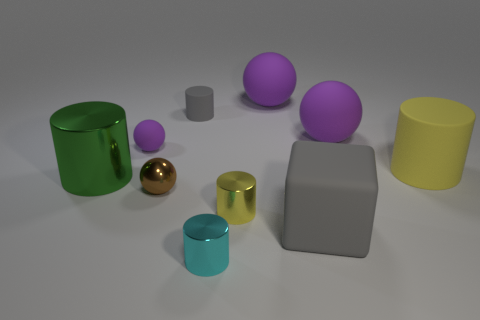Is the number of balls to the right of the tiny gray cylinder greater than the number of purple balls?
Make the answer very short. No. How many large green cylinders are behind the big yellow thing?
Ensure brevity in your answer.  0. What shape is the small thing that is the same color as the rubber block?
Make the answer very short. Cylinder. There is a gray thing that is right of the gray thing behind the small brown object; is there a small purple matte object that is in front of it?
Make the answer very short. No. Do the brown object and the gray matte cylinder have the same size?
Ensure brevity in your answer.  Yes. Is the number of yellow shiny objects that are to the left of the big shiny cylinder the same as the number of small metal things in front of the small brown ball?
Offer a terse response. No. What shape is the tiny thing behind the tiny purple rubber thing?
Offer a very short reply. Cylinder. The gray matte object that is the same size as the green shiny cylinder is what shape?
Provide a succinct answer. Cube. What is the color of the large cylinder that is behind the cylinder that is to the left of the small matte thing that is right of the brown ball?
Offer a very short reply. Yellow. Is the small purple thing the same shape as the cyan metal thing?
Keep it short and to the point. No. 